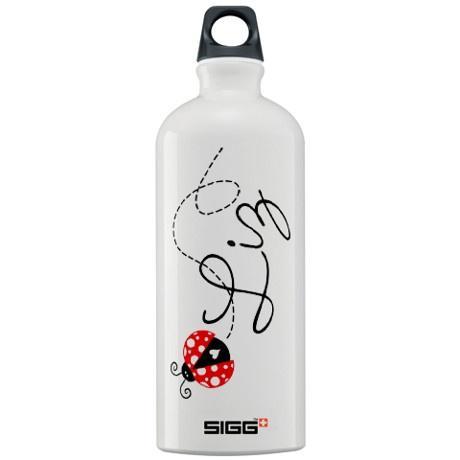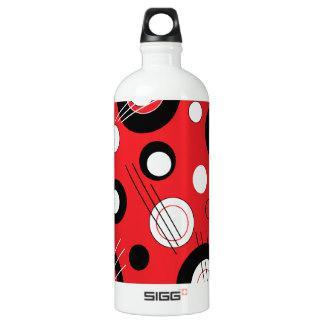The first image is the image on the left, the second image is the image on the right. Analyze the images presented: Is the assertion "A water bottle is decorated with three rows of letters on squares that spell out a word." valid? Answer yes or no. No. The first image is the image on the left, the second image is the image on the right. Given the left and right images, does the statement "One bottle has a round hole in the cap, and another bottle has an irregularly shaped hole in the cap." hold true? Answer yes or no. No. 